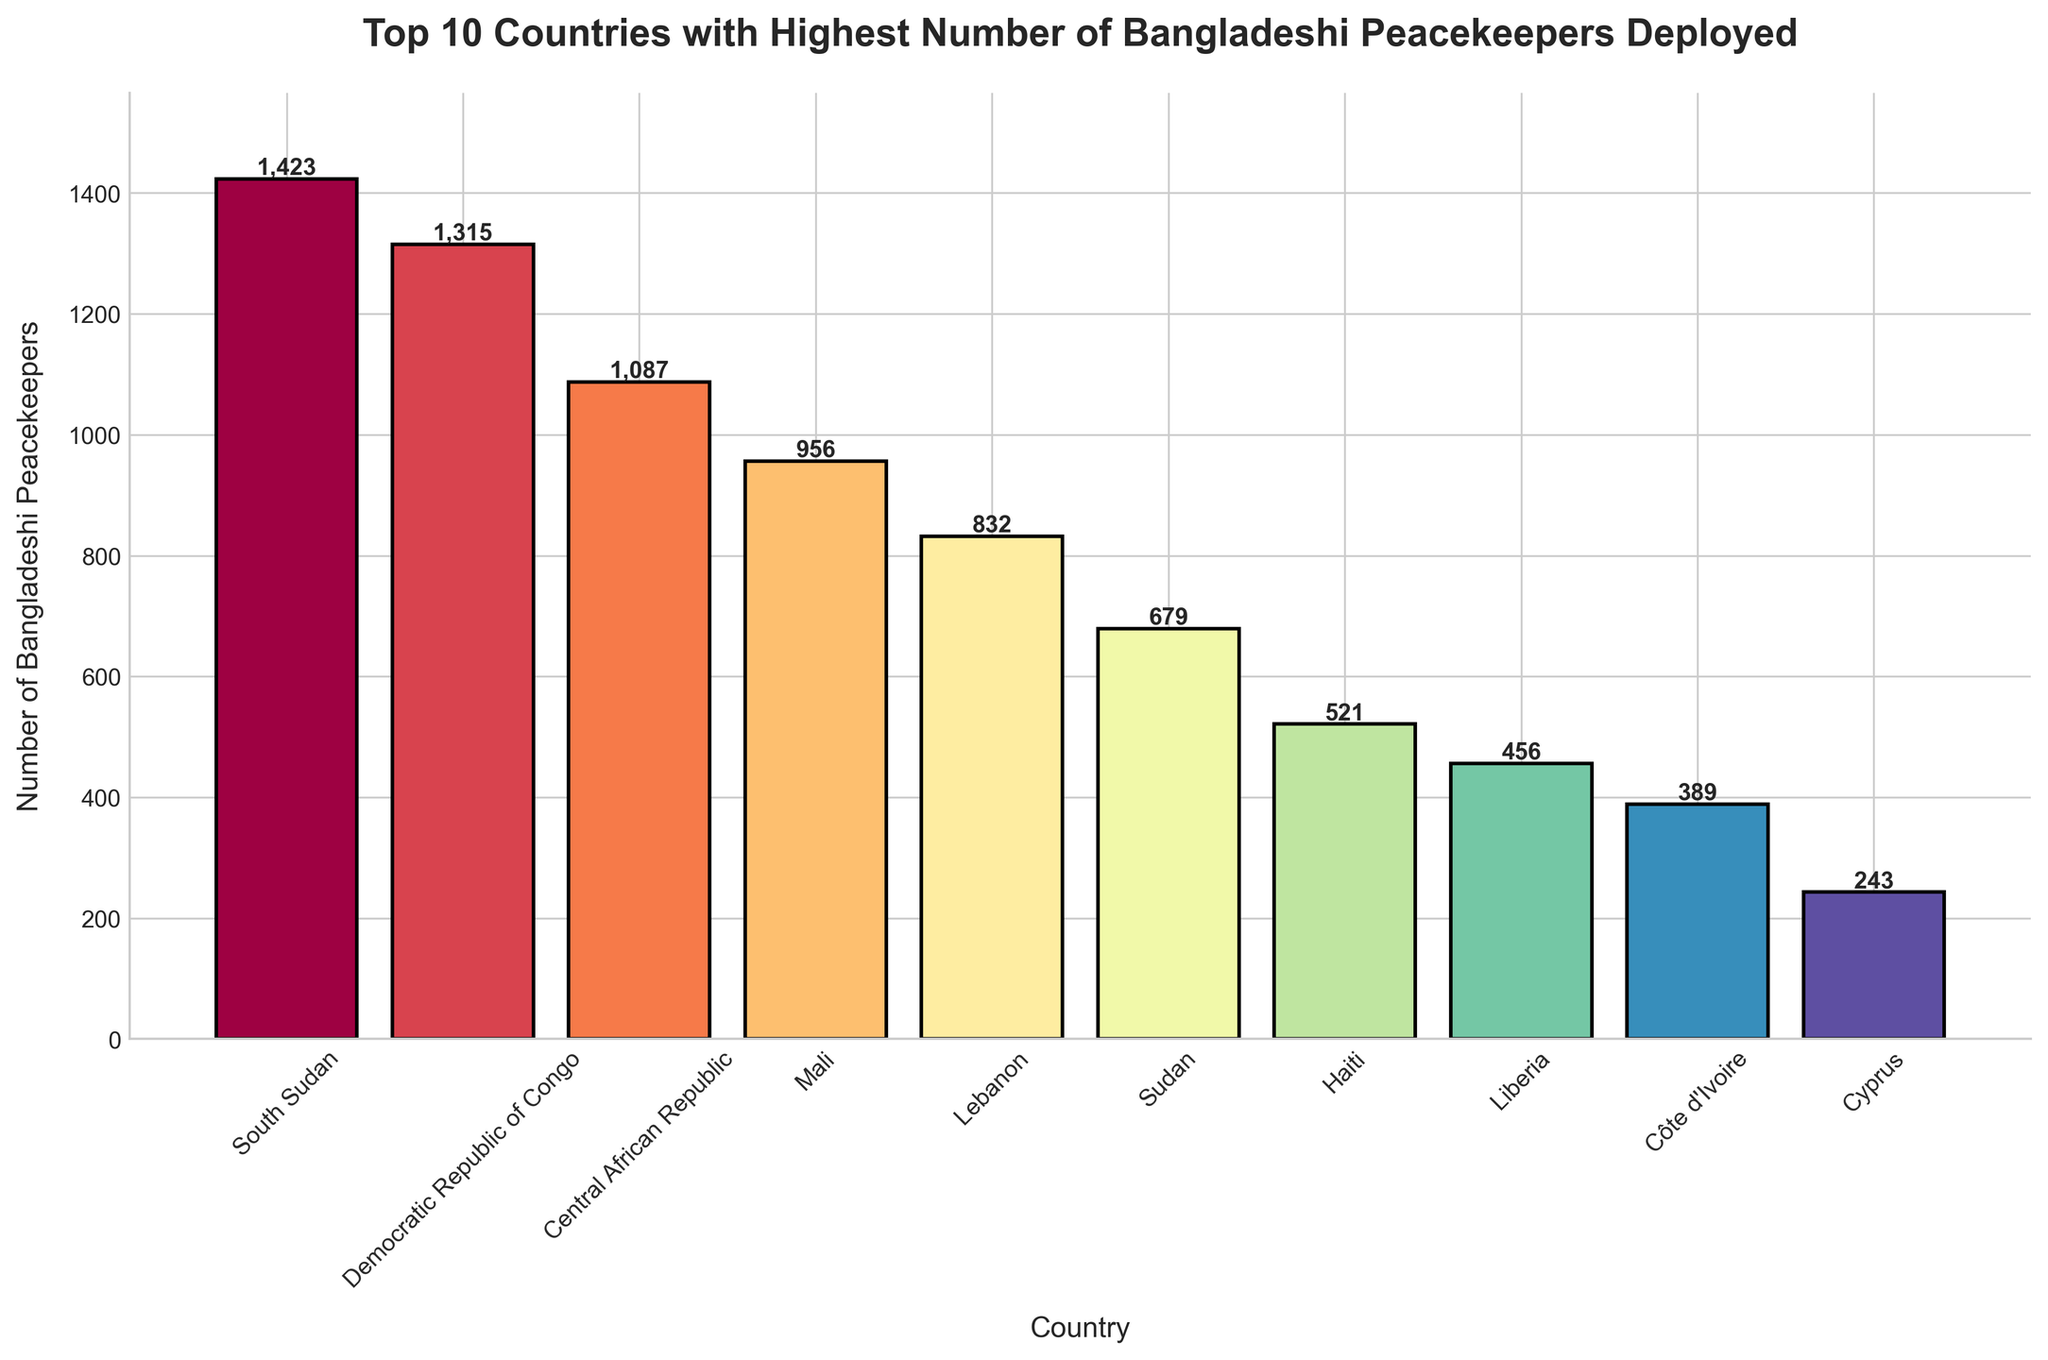Which country has the highest number of Bangladeshi peacekeepers deployed? Look at the heights of the bars in the bar chart. The bar for South Sudan is the tallest, indicating the highest number of Bangladeshi peacekeepers.
Answer: South Sudan Which country has the second highest number of Bangladeshi peacekeepers deployed? By observing the heights of the bars, the second tallest bar is for the Democratic Republic of Congo.
Answer: Democratic Republic of Congo What is the difference in the number of Bangladeshi peacekeepers between South Sudan and Central African Republic? Subtract the number of Bangladeshi peacekeepers in Central African Republic (1087) from the number in South Sudan (1423). 1423 - 1087 = 336.
Answer: 336 Which countries have deployed more than 1000 Bangladeshi peacekeepers? Look for bars with heights representing numbers greater than 1000. South Sudan (1423), Democratic Republic of Congo (1315), and Central African Republic (1087) fit this criterion.
Answer: South Sudan, Democratic Republic of Congo, Central African Republic What is the combined total number of Bangladeshi peacekeepers deployed in Sudan and Haiti? Add the number of Bangladeshi peacekeepers in Sudan (679) and Haiti (521). 679 + 521 = 1200.
Answer: 1200 How many more Bangladeshi peacekeepers are there in Mali compared to Côte d'Ivoire? Subtract the number of Bangladeshi peacekeepers in Côte d'Ivoire (389) from the number in Mali (956). 956 - 389 = 567.
Answer: 567 Which country has the least number of Bangladeshi peacekeepers deployed? Find the shortest bar in the bar chart, which represents Cyprus with 243 peacekeepers.
Answer: Cyprus How many countries have deployed between 500 and 1000 Bangladeshi peacekeepers? Identify the bars whose heights represent numbers between 500 and 1000. The countries are Mali (956), Lebanon (832), Sudan (679), and Haiti (521). There are 4 such countries.
Answer: 4 What is the average number of Bangladeshi peacekeepers deployed in the top three countries? Sum the number of Bangladeshi peacekeepers in the top three countries (South Sudan: 1423, Democratic Republic of Congo: 1315, Central African Republic: 1087), then divide by 3. (1423 + 1315 + 1087) / 3 = 381.67.
Answer: 381.67 What is the median number of Bangladeshi peacekeepers deployed across these ten countries? First, list all the numbers of Bangladeshi peacekeepers in ascending order: 243, 389, 456, 521, 679, 832, 956, 1087, 1315, 1423. The median is the average of the 5th and 6th values. (679 + 832) / 2 = 755.5.
Answer: 755.5 